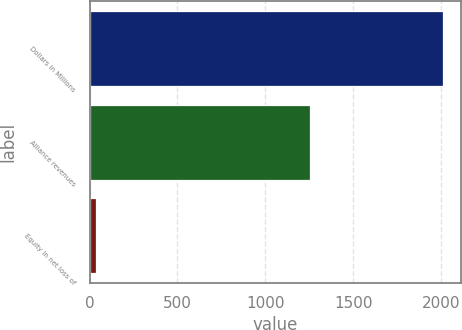<chart> <loc_0><loc_0><loc_500><loc_500><bar_chart><fcel>Dollars in Millions<fcel>Alliance revenues<fcel>Equity in net loss of<nl><fcel>2014<fcel>1255<fcel>39<nl></chart> 